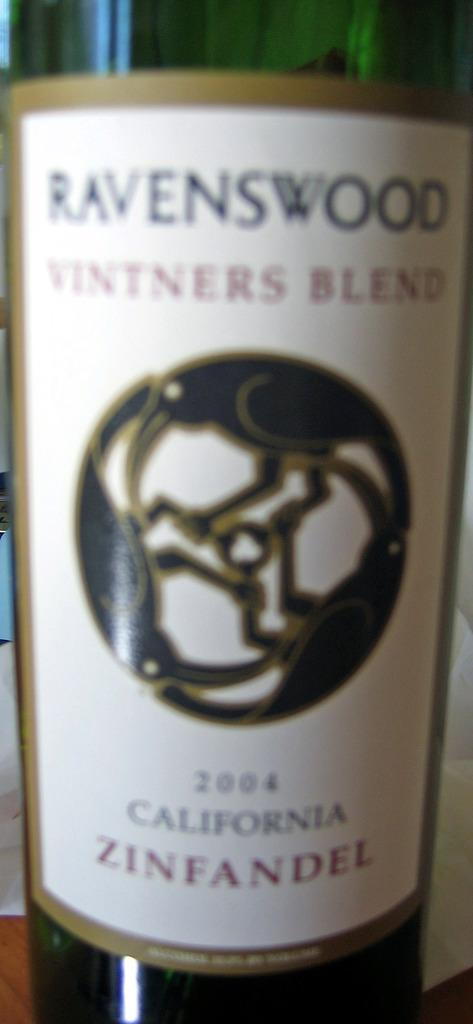<image>
Provide a brief description of the given image. A bottle of wine is dated with the year 2004 and is a Zinfandel. 